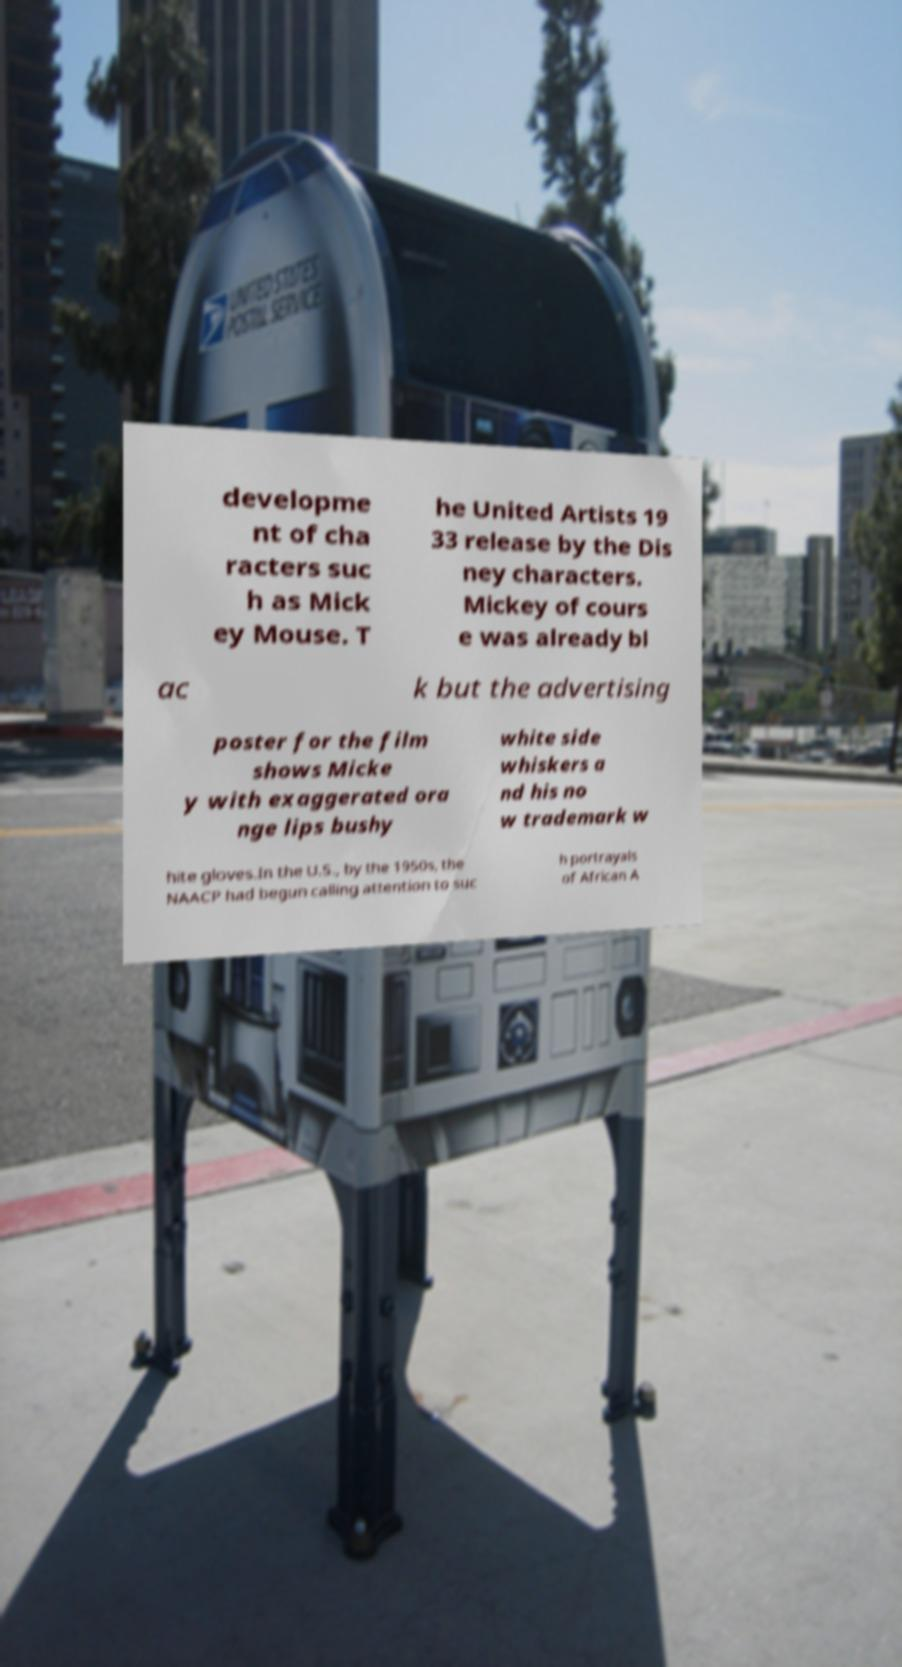Please read and relay the text visible in this image. What does it say? developme nt of cha racters suc h as Mick ey Mouse. T he United Artists 19 33 release by the Dis ney characters. Mickey of cours e was already bl ac k but the advertising poster for the film shows Micke y with exaggerated ora nge lips bushy white side whiskers a nd his no w trademark w hite gloves.In the U.S., by the 1950s, the NAACP had begun calling attention to suc h portrayals of African A 